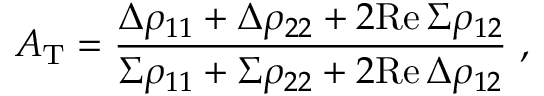Convert formula to latex. <formula><loc_0><loc_0><loc_500><loc_500>A _ { T } = { \frac { \Delta \rho _ { 1 1 } + \Delta \rho _ { 2 2 } + 2 R e \, \Sigma \rho _ { 1 2 } } { \Sigma \rho _ { 1 1 } + \Sigma \rho _ { 2 2 } + 2 R e \, \Delta \rho _ { 1 2 } } } \ ,</formula> 